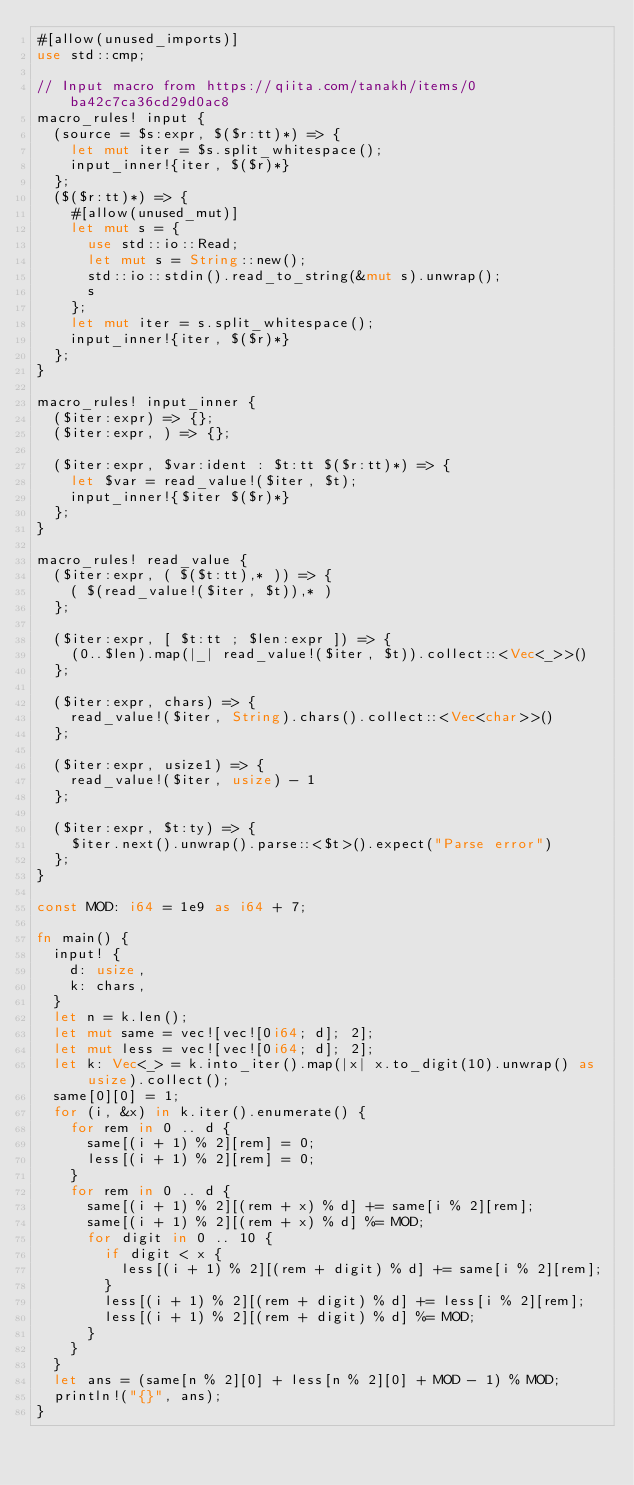Convert code to text. <code><loc_0><loc_0><loc_500><loc_500><_Rust_>#[allow(unused_imports)]
use std::cmp;

// Input macro from https://qiita.com/tanakh/items/0ba42c7ca36cd29d0ac8
macro_rules! input {
  (source = $s:expr, $($r:tt)*) => {
    let mut iter = $s.split_whitespace();
    input_inner!{iter, $($r)*}
  };
  ($($r:tt)*) => {
    #[allow(unused_mut)]
    let mut s = {
      use std::io::Read;
      let mut s = String::new();
      std::io::stdin().read_to_string(&mut s).unwrap();
      s
    };
    let mut iter = s.split_whitespace();
    input_inner!{iter, $($r)*}
  };
}

macro_rules! input_inner {
  ($iter:expr) => {};
  ($iter:expr, ) => {};

  ($iter:expr, $var:ident : $t:tt $($r:tt)*) => {
    let $var = read_value!($iter, $t);
    input_inner!{$iter $($r)*}
  };
}

macro_rules! read_value {
  ($iter:expr, ( $($t:tt),* )) => {
    ( $(read_value!($iter, $t)),* )
  };

  ($iter:expr, [ $t:tt ; $len:expr ]) => {
    (0..$len).map(|_| read_value!($iter, $t)).collect::<Vec<_>>()
  };

  ($iter:expr, chars) => {
    read_value!($iter, String).chars().collect::<Vec<char>>()
  };

  ($iter:expr, usize1) => {
    read_value!($iter, usize) - 1
  };

  ($iter:expr, $t:ty) => {
    $iter.next().unwrap().parse::<$t>().expect("Parse error")
  };
}

const MOD: i64 = 1e9 as i64 + 7;

fn main() {
  input! {
    d: usize,
    k: chars,
  }
  let n = k.len();
  let mut same = vec![vec![0i64; d]; 2];
  let mut less = vec![vec![0i64; d]; 2];
  let k: Vec<_> = k.into_iter().map(|x| x.to_digit(10).unwrap() as usize).collect();
  same[0][0] = 1;
  for (i, &x) in k.iter().enumerate() {
    for rem in 0 .. d {
      same[(i + 1) % 2][rem] = 0;
      less[(i + 1) % 2][rem] = 0;
    }
    for rem in 0 .. d {
      same[(i + 1) % 2][(rem + x) % d] += same[i % 2][rem];
      same[(i + 1) % 2][(rem + x) % d] %= MOD;
      for digit in 0 .. 10 {
        if digit < x {
          less[(i + 1) % 2][(rem + digit) % d] += same[i % 2][rem];
        }
        less[(i + 1) % 2][(rem + digit) % d] += less[i % 2][rem];
        less[(i + 1) % 2][(rem + digit) % d] %= MOD;
      }
    }
  }
  let ans = (same[n % 2][0] + less[n % 2][0] + MOD - 1) % MOD;
  println!("{}", ans);
}
</code> 